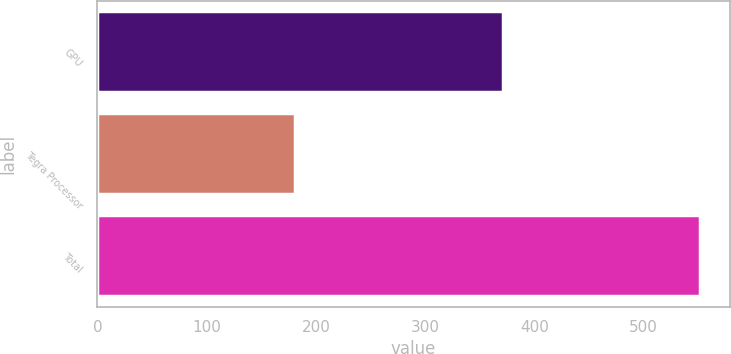<chart> <loc_0><loc_0><loc_500><loc_500><bar_chart><fcel>GPU<fcel>Tegra Processor<fcel>Total<nl><fcel>370.8<fcel>180.6<fcel>551.4<nl></chart> 